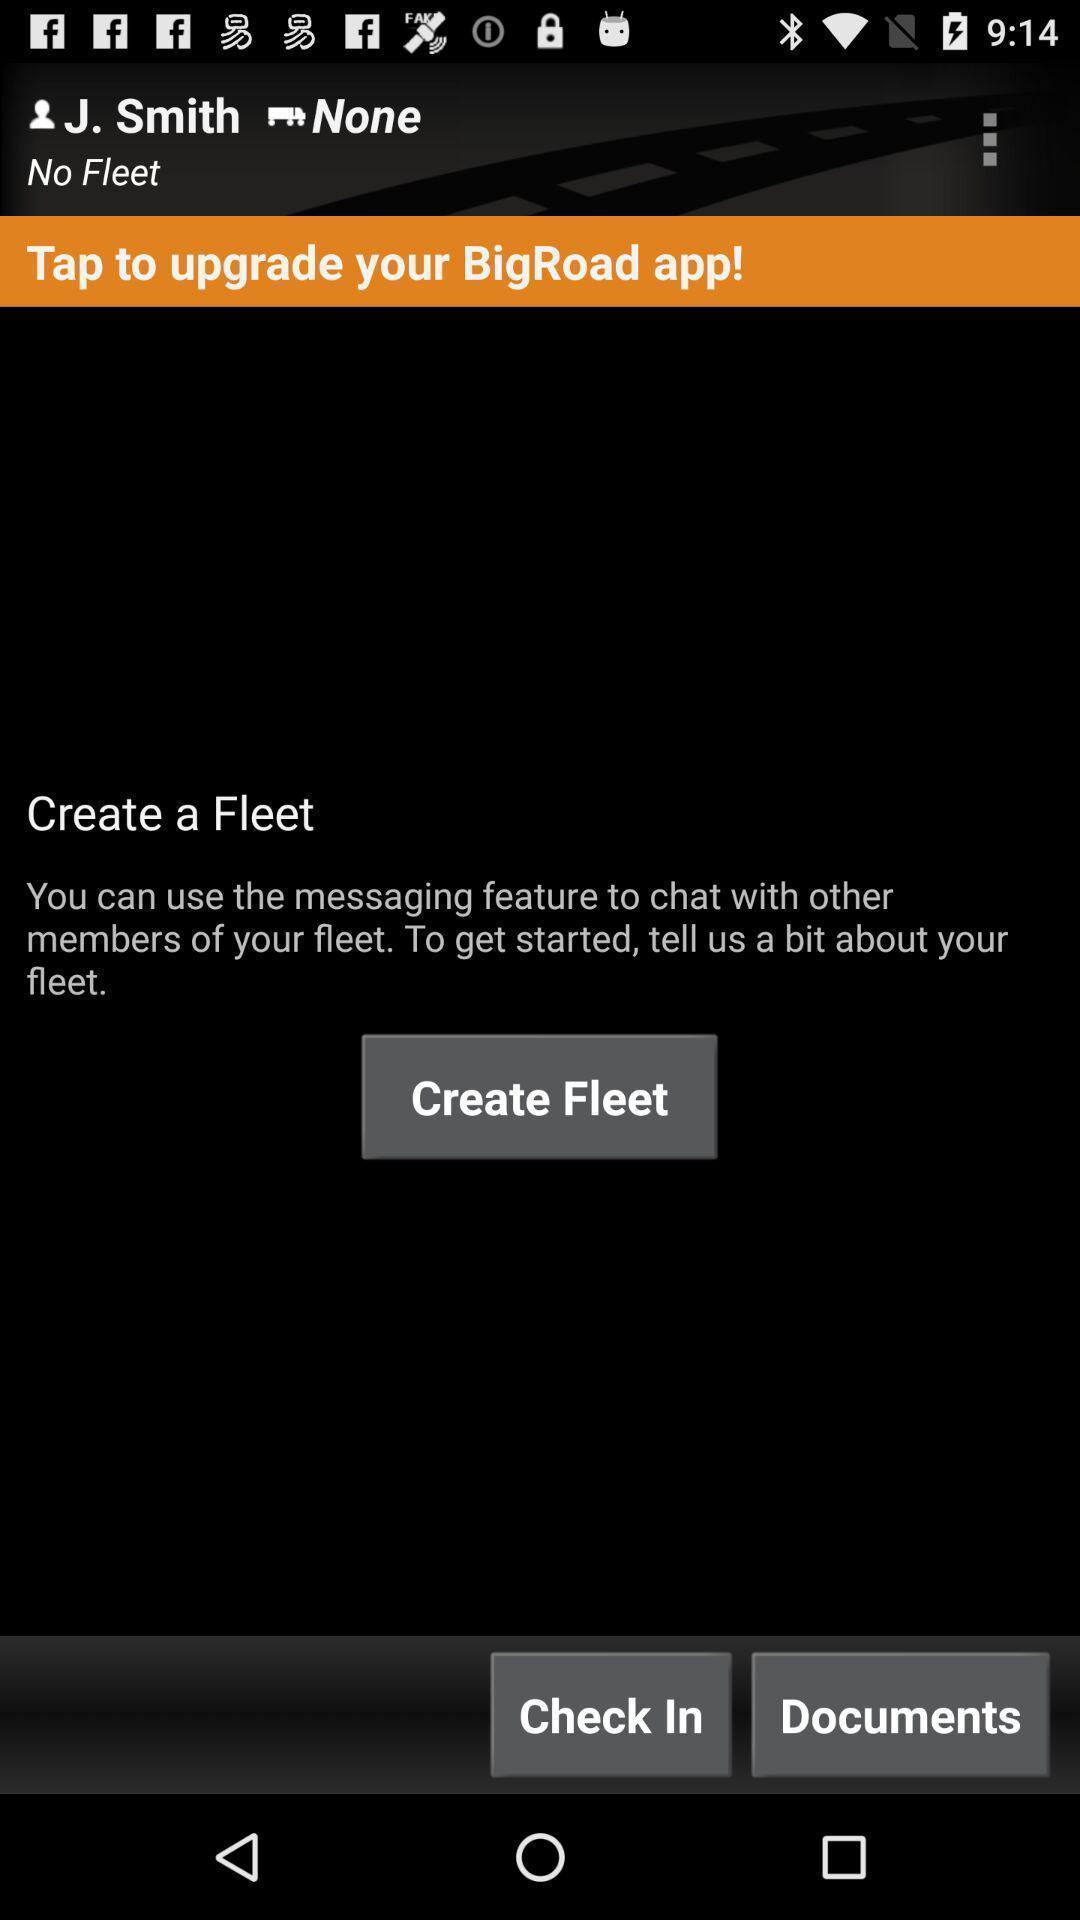Describe the content in this image. Screen displaying the option to create fleet. 